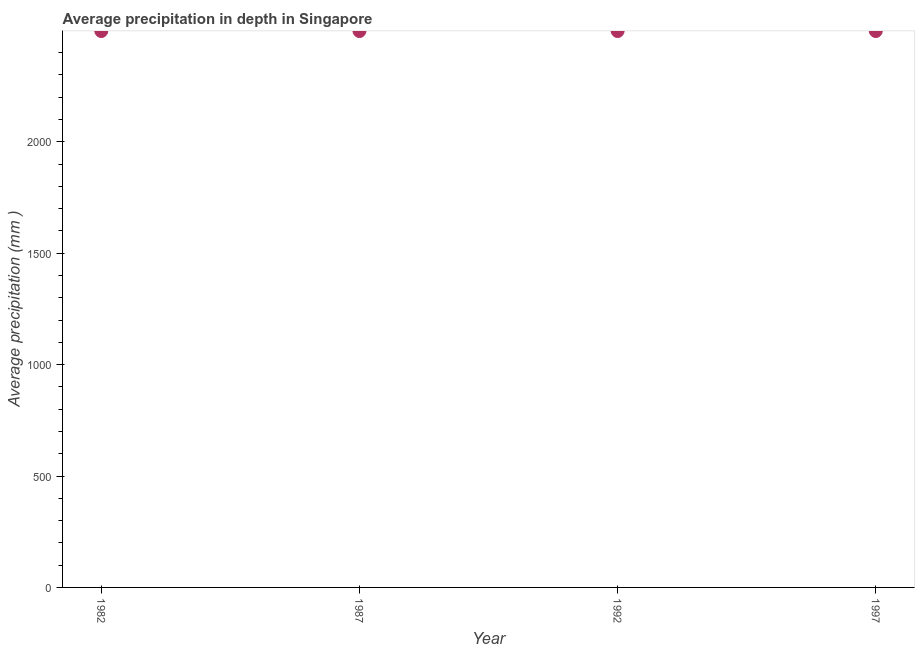What is the average precipitation in depth in 1987?
Your answer should be compact. 2497. Across all years, what is the maximum average precipitation in depth?
Your answer should be very brief. 2497. Across all years, what is the minimum average precipitation in depth?
Make the answer very short. 2497. In which year was the average precipitation in depth maximum?
Offer a terse response. 1982. In which year was the average precipitation in depth minimum?
Offer a very short reply. 1982. What is the sum of the average precipitation in depth?
Your response must be concise. 9988. What is the difference between the average precipitation in depth in 1992 and 1997?
Provide a succinct answer. 0. What is the average average precipitation in depth per year?
Your answer should be very brief. 2497. What is the median average precipitation in depth?
Your answer should be compact. 2497. In how many years, is the average precipitation in depth greater than 1400 mm?
Give a very brief answer. 4. Do a majority of the years between 1997 and 1987 (inclusive) have average precipitation in depth greater than 700 mm?
Give a very brief answer. No. What is the ratio of the average precipitation in depth in 1987 to that in 1992?
Ensure brevity in your answer.  1. Is the average precipitation in depth in 1982 less than that in 1987?
Give a very brief answer. No. What is the difference between the highest and the second highest average precipitation in depth?
Offer a very short reply. 0. In how many years, is the average precipitation in depth greater than the average average precipitation in depth taken over all years?
Your answer should be very brief. 0. How many dotlines are there?
Keep it short and to the point. 1. How many years are there in the graph?
Provide a succinct answer. 4. What is the difference between two consecutive major ticks on the Y-axis?
Make the answer very short. 500. Are the values on the major ticks of Y-axis written in scientific E-notation?
Keep it short and to the point. No. What is the title of the graph?
Provide a short and direct response. Average precipitation in depth in Singapore. What is the label or title of the Y-axis?
Offer a terse response. Average precipitation (mm ). What is the Average precipitation (mm ) in 1982?
Provide a short and direct response. 2497. What is the Average precipitation (mm ) in 1987?
Keep it short and to the point. 2497. What is the Average precipitation (mm ) in 1992?
Ensure brevity in your answer.  2497. What is the Average precipitation (mm ) in 1997?
Make the answer very short. 2497. What is the difference between the Average precipitation (mm ) in 1987 and 1997?
Offer a terse response. 0. What is the difference between the Average precipitation (mm ) in 1992 and 1997?
Ensure brevity in your answer.  0. What is the ratio of the Average precipitation (mm ) in 1982 to that in 1997?
Offer a very short reply. 1. What is the ratio of the Average precipitation (mm ) in 1987 to that in 1992?
Your answer should be very brief. 1. 